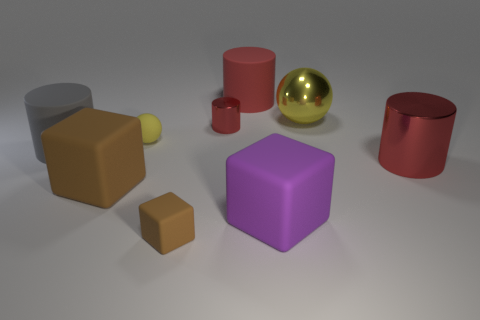How many red cylinders must be subtracted to get 1 red cylinders? 2 Subtract all brown blocks. How many blocks are left? 1 Subtract all purple blocks. How many blocks are left? 2 Subtract all spheres. How many objects are left? 7 Subtract all brown blocks. How many gray cylinders are left? 1 Add 1 red metal things. How many objects exist? 10 Subtract 0 gray spheres. How many objects are left? 9 Subtract 1 balls. How many balls are left? 1 Subtract all blue cylinders. Subtract all cyan cubes. How many cylinders are left? 4 Subtract all brown rubber things. Subtract all large red shiny objects. How many objects are left? 6 